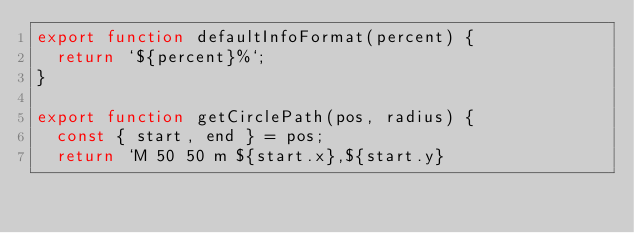Convert code to text. <code><loc_0><loc_0><loc_500><loc_500><_JavaScript_>export function defaultInfoFormat(percent) {
  return `${percent}%`;
}

export function getCirclePath(pos, radius) {
  const { start, end } = pos;
  return `M 50 50 m ${start.x},${start.y}</code> 